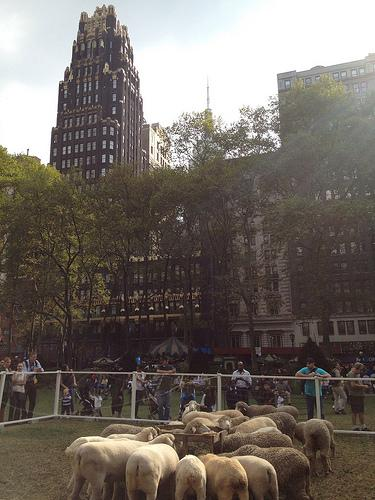Count the number of narrow building windows with black frames mentioned in the image. There are 8 narrow building windows with black frames mentioned. Identify an object in the background that provides shade. A blue and white awning over the building provides shade in the background. What is the sentiment of the image, based on the activities and atmosphere? The sentiment of the image is joyful and leisurely, as people and families are enjoying their time watching the sheep together. Describe any interactions between the people and animals in the image. People are watching the sheep as they eat from a feed trough, while the man and his daughter look at the sheep closely. Assess the presence of livestock in the image. There are several off-white sheered sheep and one dirty off-white sheep unsheered, feeding and interacting with people watching them. List any visible family activities and interaction in the image. Family activities and interactions include watching the sheep, a woman pushing a baby stroller, a man with headphones on, a man and his daughter looking at sheep, and a woman with her child and a stroller. What are the children in the image doing? The children in the image are watching sheep and standing around with their family. How many off-white sheered sheep are there in the image? There are 6 off-white sheered sheep in the image. Examine the image and describe one man's outfit. One man is wearing a light blue shirt, a hat, and possibly a backpack, while standing and watching the sheep. Identify the main event taking place in this image. family watching the sheep Identify an event occurring in this image involving a man with headphones on. man with headphones watching sheep Construct a vivid description of the scene involving a man in a light blue shirt and a group of people watching sheep. On an idyllic day, a man in a light blue shirt stands among a mesmerized crowd, who are all captivated by the sight of fluffy sheep feasting in their enclosure. The air is filled with excitement as laughter and chatter rise from the onlookers. Produce a rhyming couplet about the woman with the baby stroller. A woman, her stroller steadfast and true, List any visible text on the objects in the image. No visible text Determine whether the narrow windows in the image are similar or different. similar with black frames What is the expression of the woman pushing the baby stroller? Cannot determine expression What are the numbers visible on any object in the image? No numbers visible Explain the layout and the purpose of the objects in the image. Not a diagram image Briefly describe the appearance of the sheep in the center of the photo. off-white, sheered, eating Create a short story involving the depicted scene with a man in a blue shirt and off white sheered sheep. One sunny afternoon, a man in a blue shirt visited a quaint village fair. He stopped by the lively sheep pen, where off-white sheered sheep were happily munching away. As he observed the lively animals, he couldn't help but feel a sense of tranquility. What are the people in front of the fence doing? watching the sheep What activity are the sheep engaged in? feeding in a feed trough What color is the awning over the building? blue and white Describe the object near the short woman watching the scene. green and yellow grass Point out the position of the church steeple in the image. behind the trees Describe the appearance of the building with many floors in a poetic manner. A beautiful old edifice with countless layers of stories stands tall, casting a shadow over the scene. Which object is located at the upper left corner of the image and has many floors? beautiful old building 